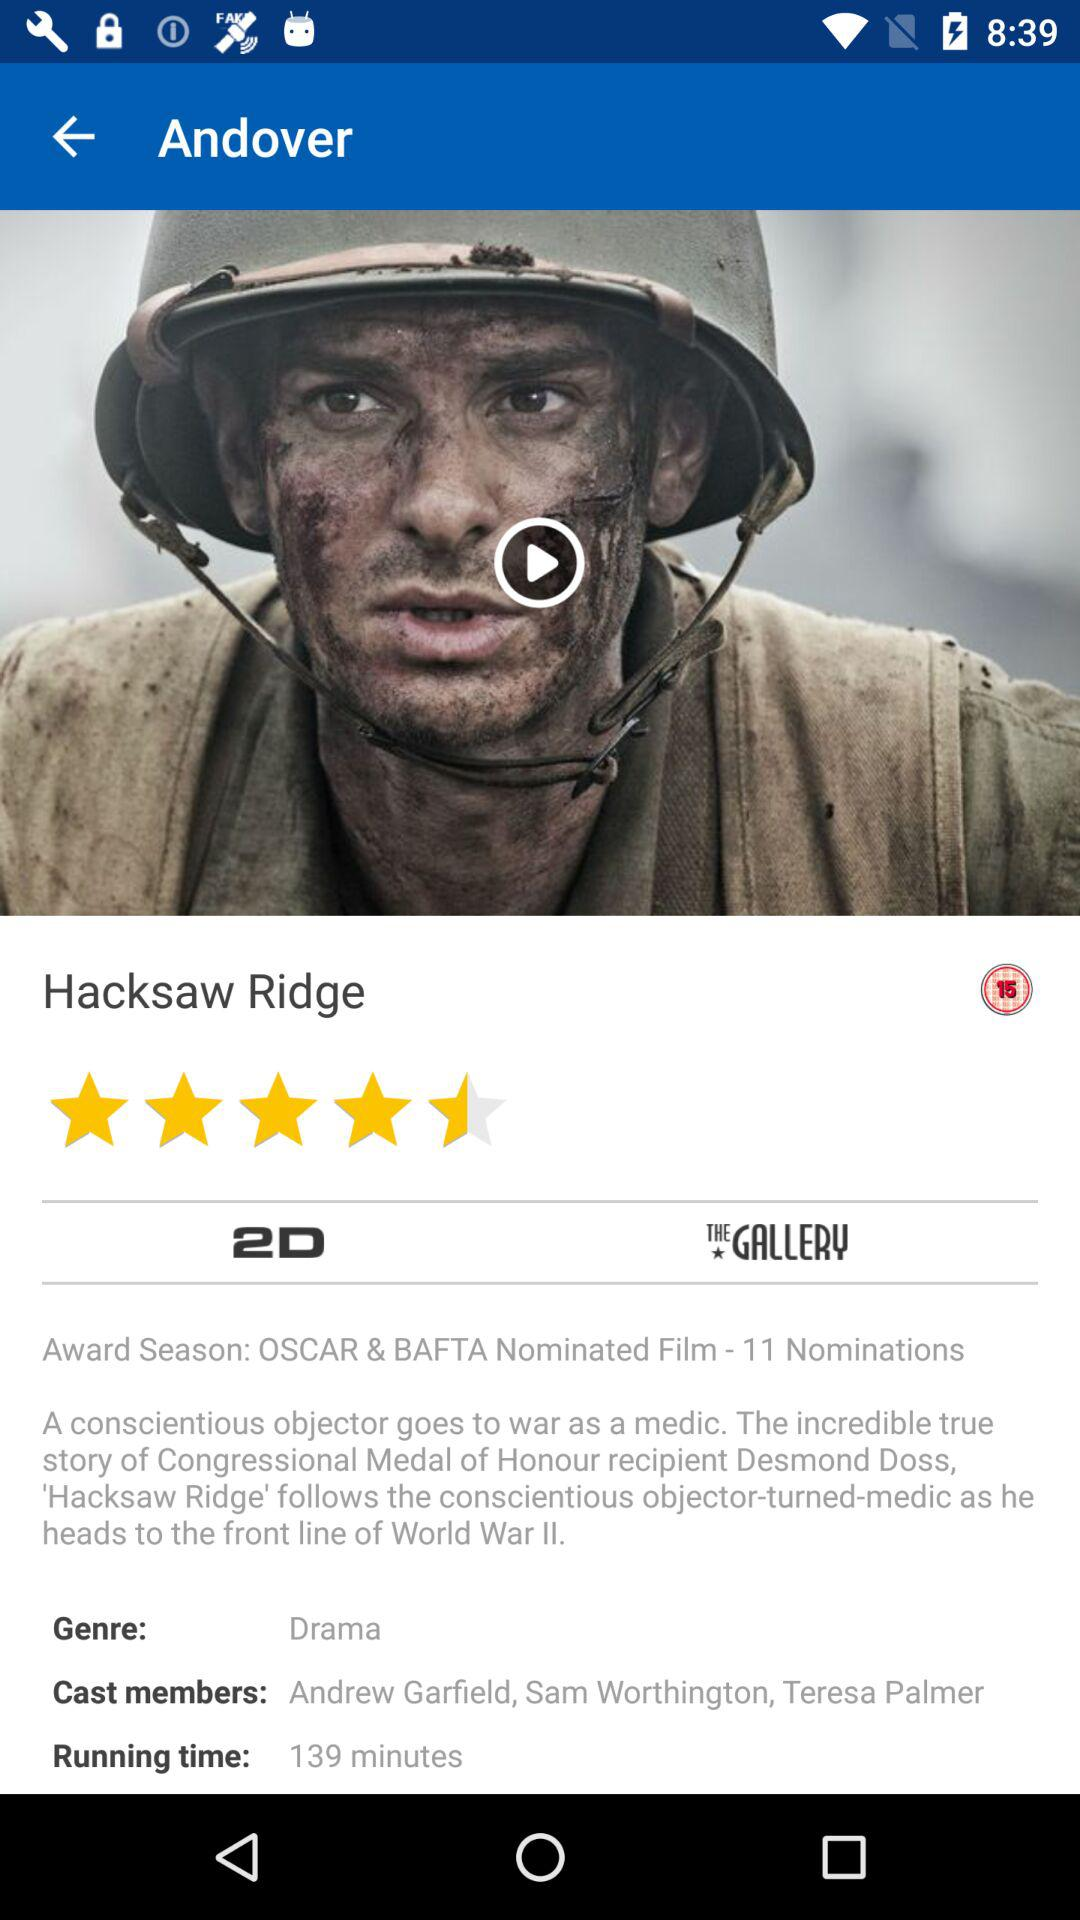What is the running time of the movie?
Answer the question using a single word or phrase. 139 minutes 